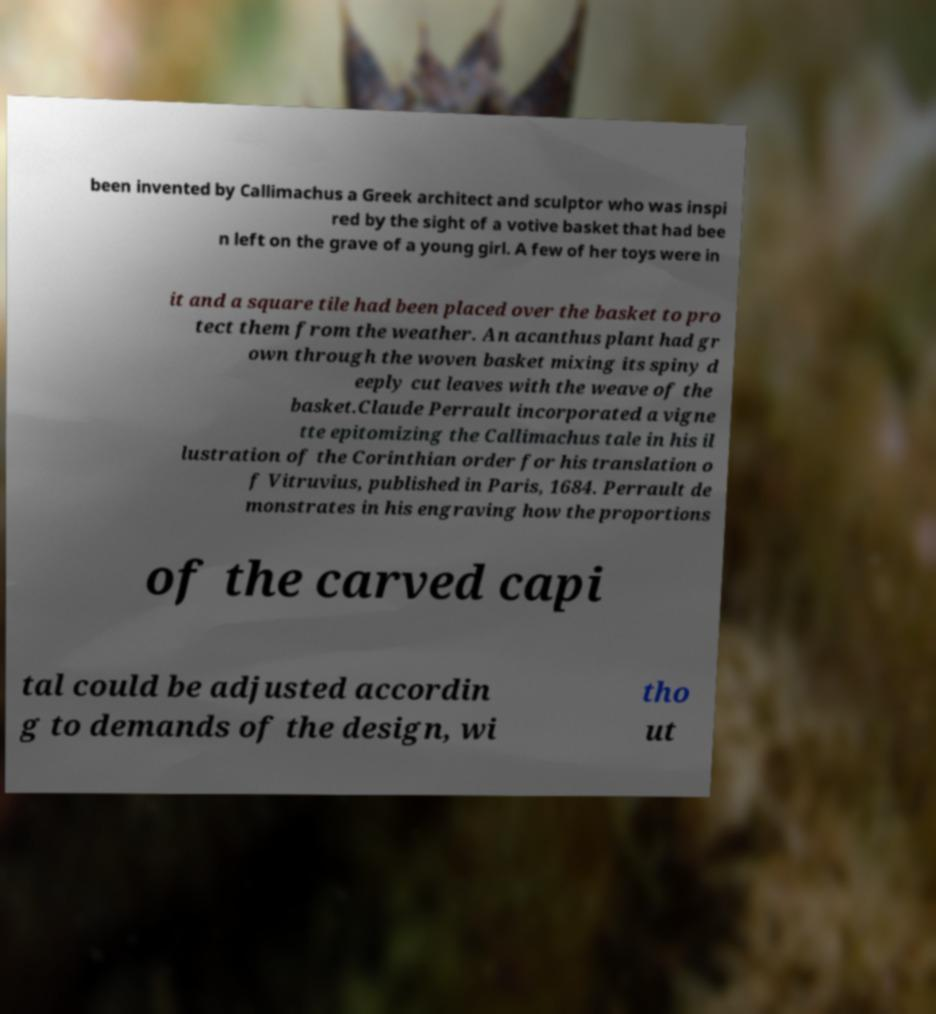Can you read and provide the text displayed in the image?This photo seems to have some interesting text. Can you extract and type it out for me? been invented by Callimachus a Greek architect and sculptor who was inspi red by the sight of a votive basket that had bee n left on the grave of a young girl. A few of her toys were in it and a square tile had been placed over the basket to pro tect them from the weather. An acanthus plant had gr own through the woven basket mixing its spiny d eeply cut leaves with the weave of the basket.Claude Perrault incorporated a vigne tte epitomizing the Callimachus tale in his il lustration of the Corinthian order for his translation o f Vitruvius, published in Paris, 1684. Perrault de monstrates in his engraving how the proportions of the carved capi tal could be adjusted accordin g to demands of the design, wi tho ut 